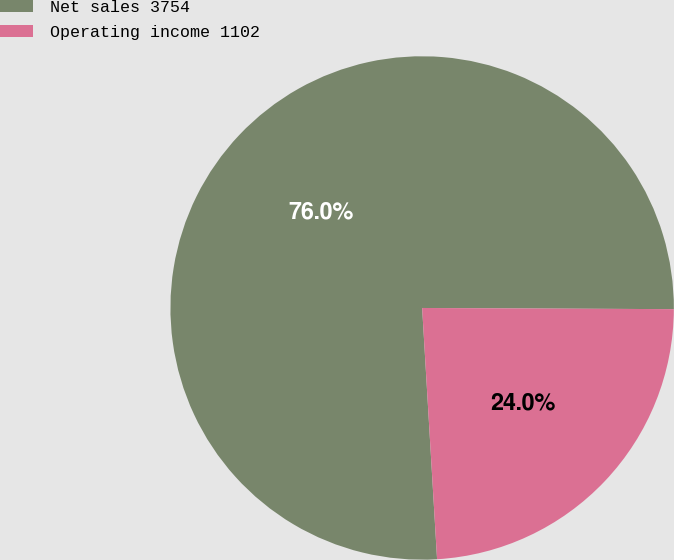Convert chart to OTSL. <chart><loc_0><loc_0><loc_500><loc_500><pie_chart><fcel>Net sales 3754<fcel>Operating income 1102<nl><fcel>76.02%<fcel>23.98%<nl></chart> 